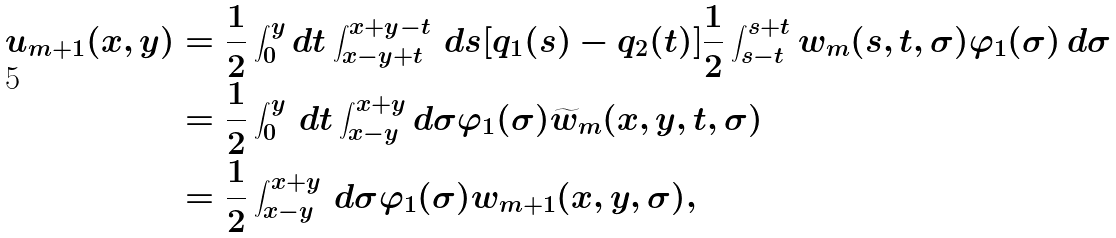Convert formula to latex. <formula><loc_0><loc_0><loc_500><loc_500>u _ { m + 1 } ( x , y ) & = \frac { 1 } { 2 } \int ^ { y } _ { 0 } d t \int ^ { x + y - t } _ { x - y + t } \, d s [ q _ { 1 } ( s ) - q _ { 2 } ( t ) ] \frac { 1 } { 2 } \int ^ { s + t } _ { s - t } w _ { m } ( s , t , \sigma ) \varphi _ { 1 } ( \sigma ) \, d \sigma \\ & = \frac { 1 } { 2 } \int ^ { y } _ { 0 } \, d t \int ^ { x + y } _ { x - y } d \sigma \varphi _ { 1 } ( \sigma ) \widetilde { w } _ { m } ( x , y , t , \sigma ) \\ & = \frac { 1 } { 2 } \int ^ { x + y } _ { x - y } \, d \sigma \varphi _ { 1 } ( \sigma ) w _ { m + 1 } ( x , y , \sigma ) ,</formula> 